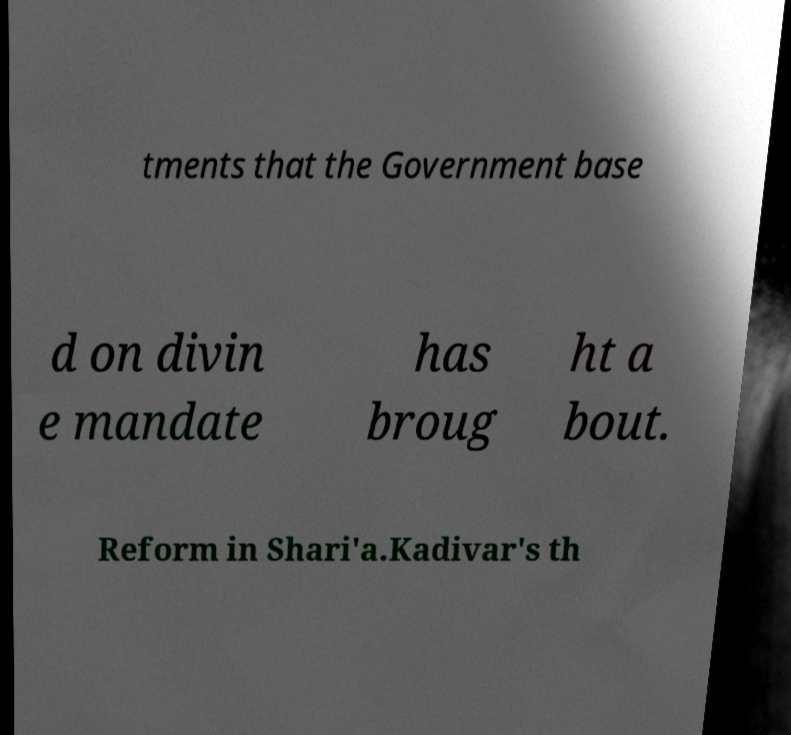For documentation purposes, I need the text within this image transcribed. Could you provide that? tments that the Government base d on divin e mandate has broug ht a bout. Reform in Shari'a.Kadivar's th 